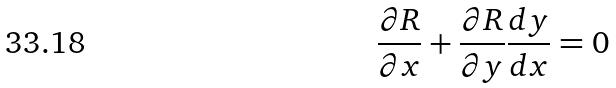Convert formula to latex. <formula><loc_0><loc_0><loc_500><loc_500>\frac { \partial R } { \partial x } + \frac { \partial R } { \partial y } \frac { d y } { d x } = 0</formula> 